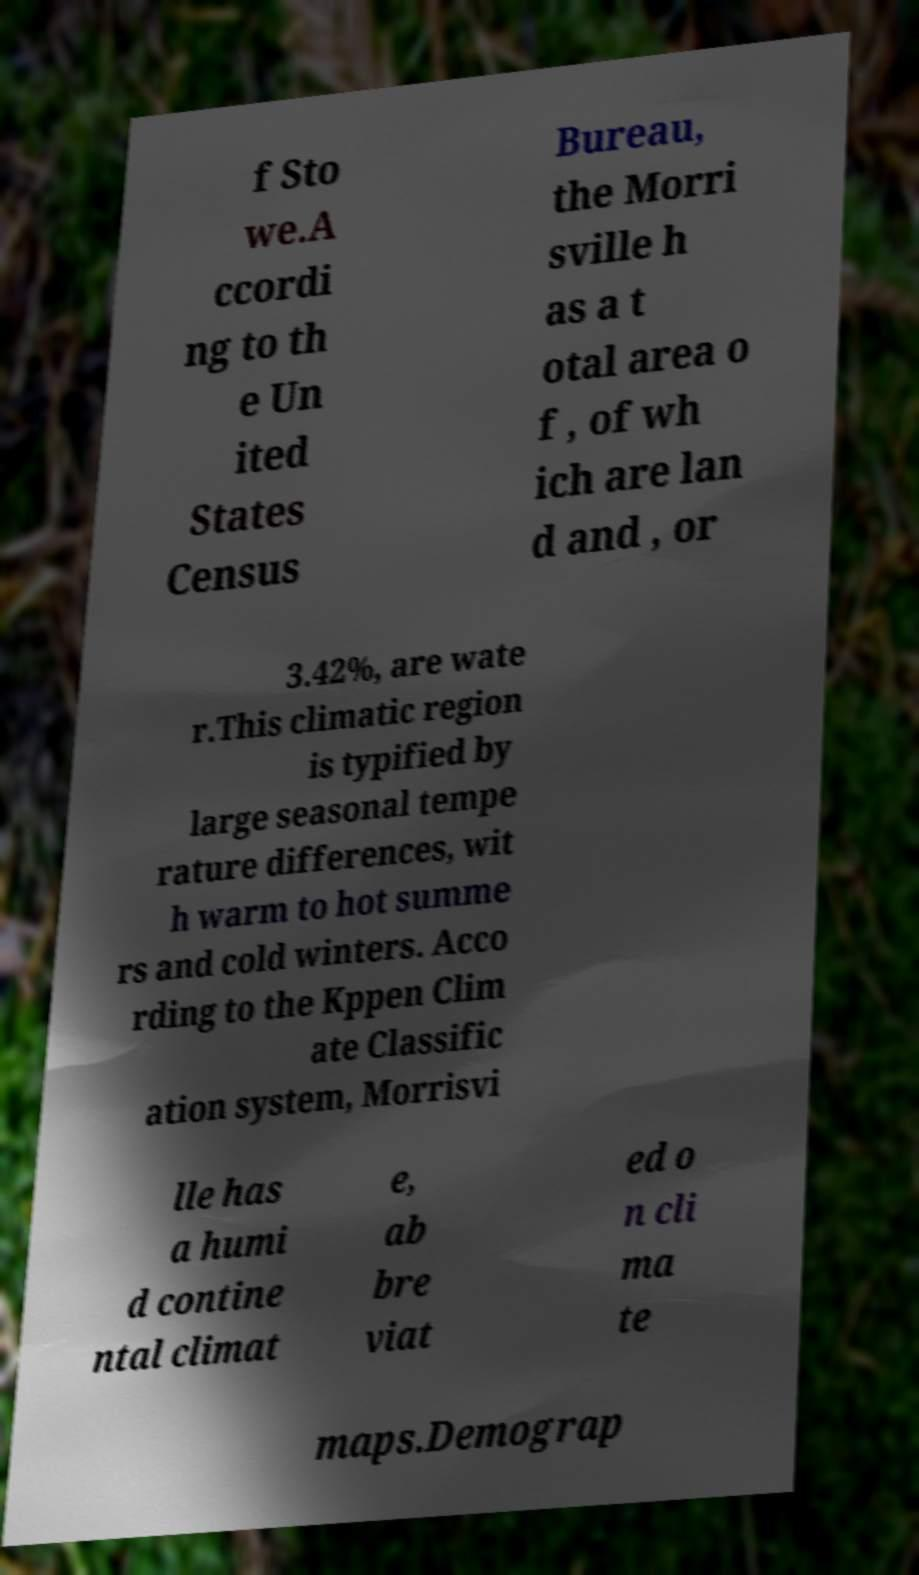Please identify and transcribe the text found in this image. f Sto we.A ccordi ng to th e Un ited States Census Bureau, the Morri sville h as a t otal area o f , of wh ich are lan d and , or 3.42%, are wate r.This climatic region is typified by large seasonal tempe rature differences, wit h warm to hot summe rs and cold winters. Acco rding to the Kppen Clim ate Classific ation system, Morrisvi lle has a humi d contine ntal climat e, ab bre viat ed o n cli ma te maps.Demograp 